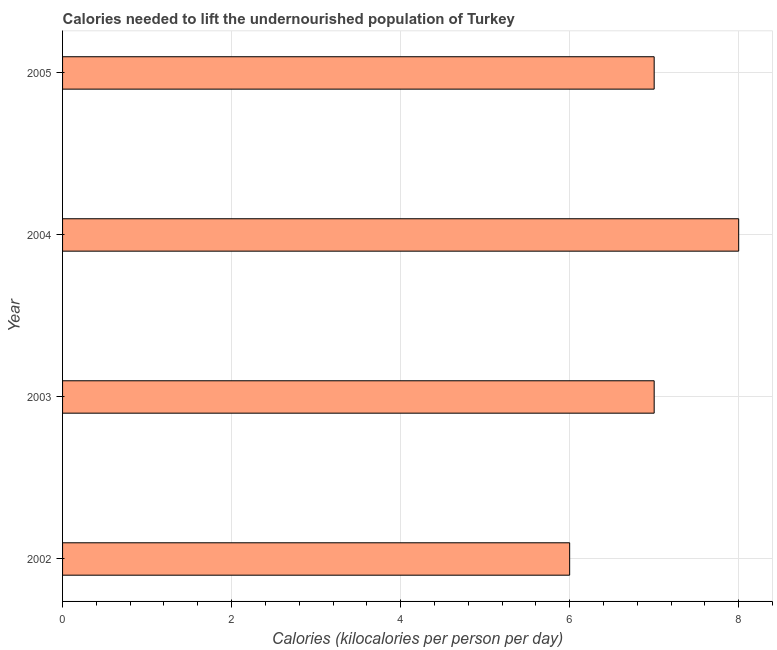Does the graph contain any zero values?
Offer a very short reply. No. What is the title of the graph?
Your response must be concise. Calories needed to lift the undernourished population of Turkey. What is the label or title of the X-axis?
Ensure brevity in your answer.  Calories (kilocalories per person per day). What is the depth of food deficit in 2003?
Your answer should be compact. 7. Across all years, what is the maximum depth of food deficit?
Keep it short and to the point. 8. In which year was the depth of food deficit maximum?
Your answer should be very brief. 2004. What is the sum of the depth of food deficit?
Give a very brief answer. 28. Do a majority of the years between 2002 and 2004 (inclusive) have depth of food deficit greater than 1.6 kilocalories?
Provide a short and direct response. Yes. Is the depth of food deficit in 2003 less than that in 2004?
Provide a short and direct response. Yes. Is the sum of the depth of food deficit in 2002 and 2003 greater than the maximum depth of food deficit across all years?
Give a very brief answer. Yes. What is the difference between the highest and the lowest depth of food deficit?
Provide a short and direct response. 2. In how many years, is the depth of food deficit greater than the average depth of food deficit taken over all years?
Your answer should be compact. 1. Are all the bars in the graph horizontal?
Offer a terse response. Yes. What is the difference between two consecutive major ticks on the X-axis?
Give a very brief answer. 2. Are the values on the major ticks of X-axis written in scientific E-notation?
Offer a terse response. No. What is the Calories (kilocalories per person per day) of 2004?
Provide a short and direct response. 8. What is the difference between the Calories (kilocalories per person per day) in 2002 and 2003?
Offer a terse response. -1. What is the difference between the Calories (kilocalories per person per day) in 2002 and 2004?
Offer a terse response. -2. What is the difference between the Calories (kilocalories per person per day) in 2002 and 2005?
Your answer should be compact. -1. What is the difference between the Calories (kilocalories per person per day) in 2003 and 2004?
Offer a terse response. -1. What is the difference between the Calories (kilocalories per person per day) in 2003 and 2005?
Your answer should be very brief. 0. What is the difference between the Calories (kilocalories per person per day) in 2004 and 2005?
Offer a very short reply. 1. What is the ratio of the Calories (kilocalories per person per day) in 2002 to that in 2003?
Provide a short and direct response. 0.86. What is the ratio of the Calories (kilocalories per person per day) in 2002 to that in 2004?
Your answer should be very brief. 0.75. What is the ratio of the Calories (kilocalories per person per day) in 2002 to that in 2005?
Make the answer very short. 0.86. What is the ratio of the Calories (kilocalories per person per day) in 2004 to that in 2005?
Your answer should be very brief. 1.14. 